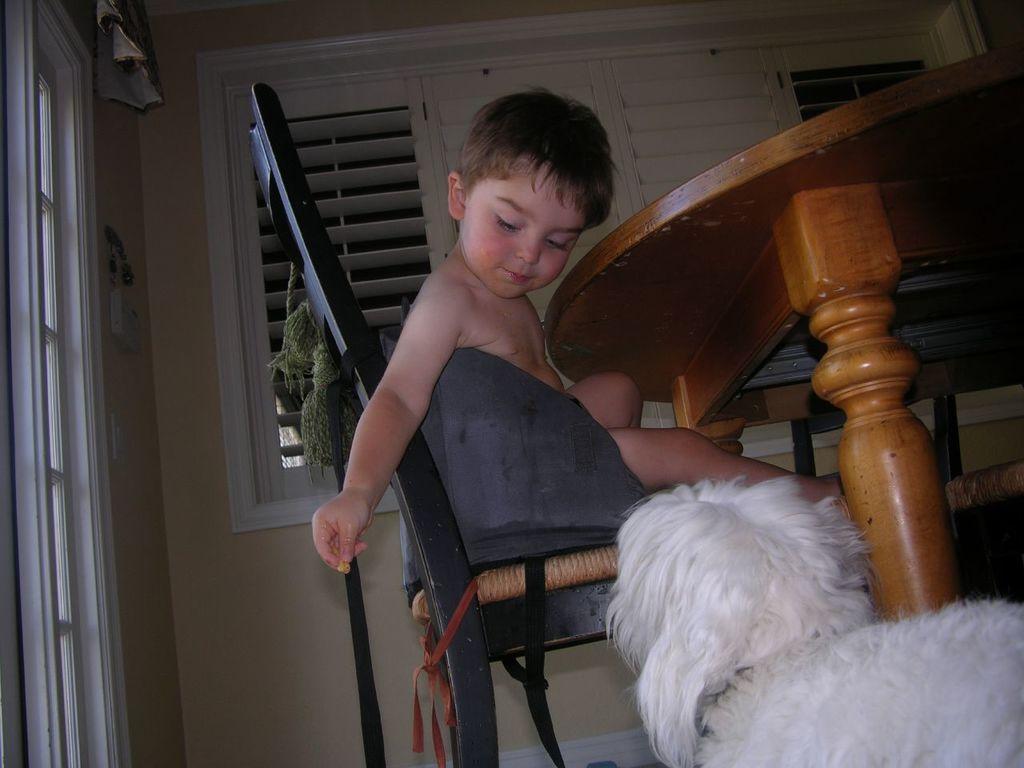In one or two sentences, can you explain what this image depicts? In this image there is a kid sitting on the chair. Right bottom there is an animal. Beside there is a table. Background there are windows to the wall. 